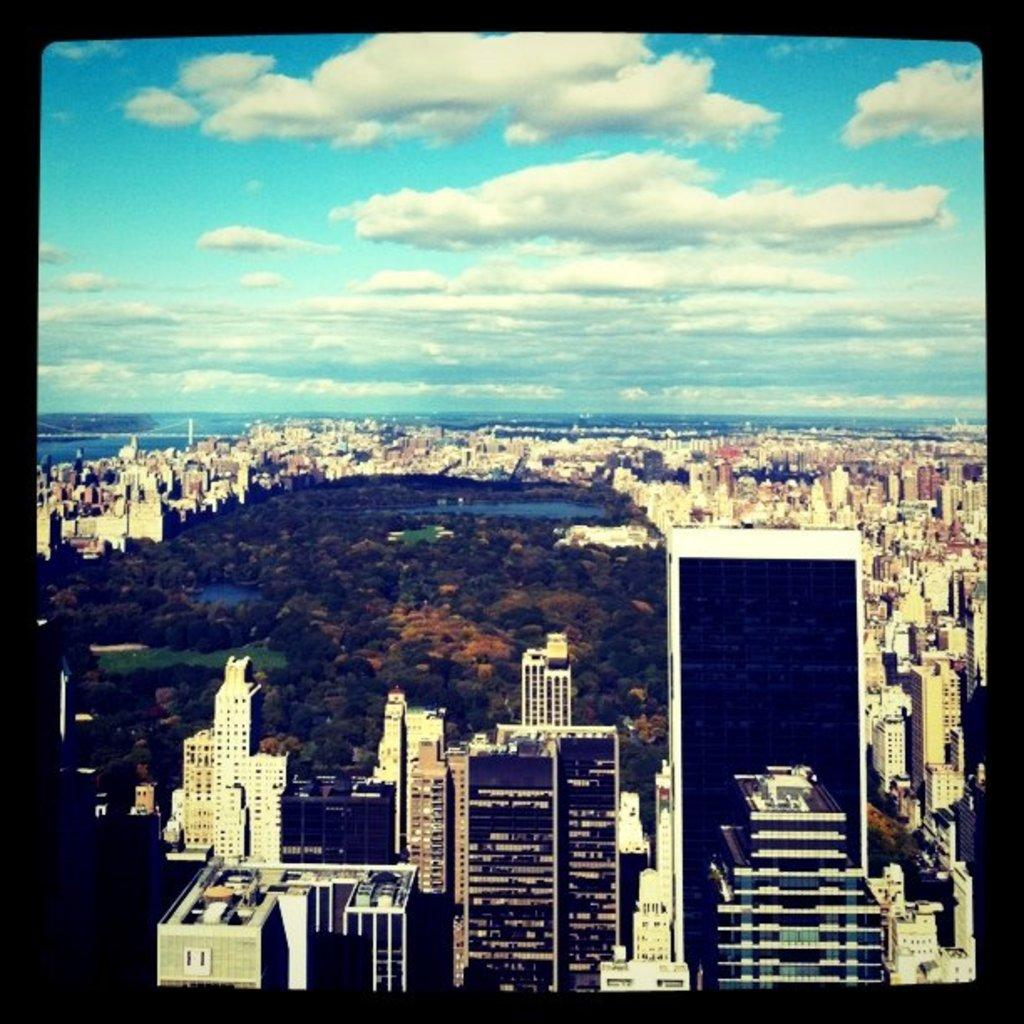What type of structures can be seen in the image? There are buildings in the image. What other natural elements are present in the image? There are trees and water in the middle of the trees. What can be seen in the background of the image? The sky is visible in the background of the image. What type of riddle can be solved by observing the mind of the squirrel in the image? There is no squirrel present in the image, and therefore no riddle related to a squirrel's mind can be solved. 